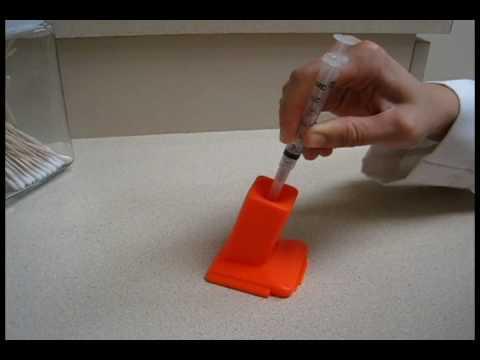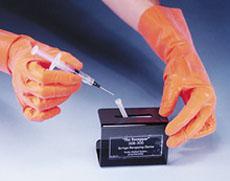The first image is the image on the left, the second image is the image on the right. For the images displayed, is the sentence "A person is inserting a syringe into an orange holder." factually correct? Answer yes or no. Yes. 